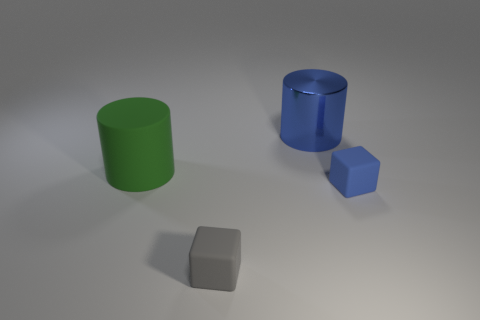Add 3 large metal objects. How many objects exist? 7 Add 3 small red cylinders. How many small red cylinders exist? 3 Subtract 0 cyan cylinders. How many objects are left? 4 Subtract all gray blocks. Subtract all tiny yellow shiny objects. How many objects are left? 3 Add 2 blue rubber objects. How many blue rubber objects are left? 3 